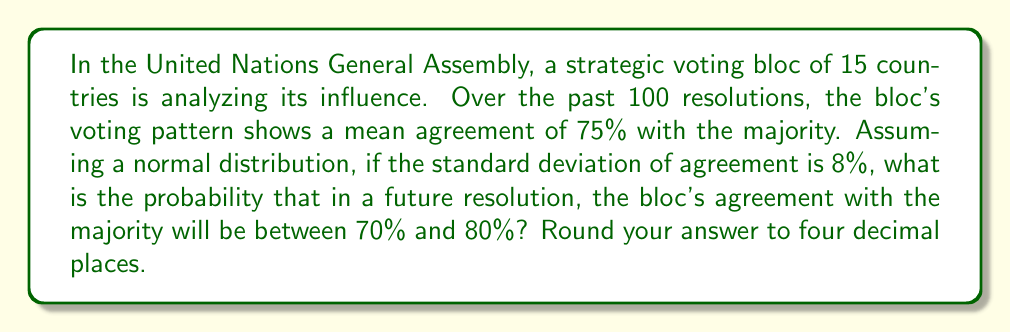What is the answer to this math problem? To solve this problem, we'll use the properties of the normal distribution and the z-score formula. Let's approach this step-by-step:

1) We're given:
   - Mean (μ) = 75%
   - Standard deviation (σ) = 8%
   - We want to find P(70% < X < 80%)

2) First, we need to calculate the z-scores for both 70% and 80%:

   z = (x - μ) / σ

   For 70%: z₁ = (70 - 75) / 8 = -0.625
   For 80%: z₂ = (80 - 75) / 8 = 0.625

3) Now, we need to find the area under the standard normal curve between these two z-scores.

4) Using a standard normal distribution table or calculator:
   P(Z < -0.625) ≈ 0.2660
   P(Z < 0.625) ≈ 0.7340

5) The probability we're looking for is the difference between these two values:

   P(-0.625 < Z < 0.625) = P(Z < 0.625) - P(Z < -0.625)
                          = 0.7340 - 0.2660
                          = 0.4680

6) Rounding to four decimal places:

   P(70% < X < 80%) ≈ 0.4680

This result indicates that there's approximately a 46.80% chance that in a future resolution, the bloc's agreement with the majority will be between 70% and 80%.
Answer: 0.4680 